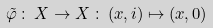Convert formula to latex. <formula><loc_0><loc_0><loc_500><loc_500>\tilde { \varphi } \, \colon \, X \to X \, \colon \, ( x , i ) \mapsto ( x , 0 )</formula> 